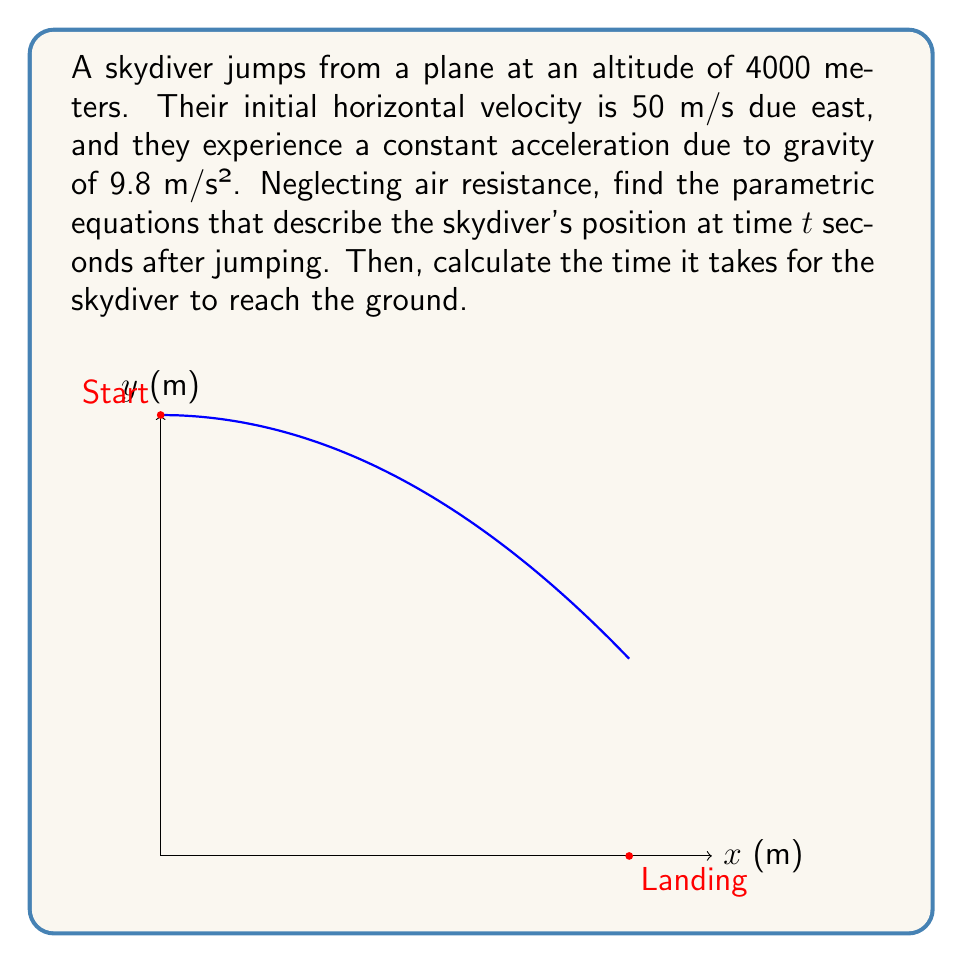Show me your answer to this math problem. Let's approach this step-by-step:

1) First, we need to set up our coordinate system. Let's use:
   - x-axis: horizontal distance traveled (positive eastward)
   - y-axis: altitude
   - t: time in seconds since the jump

2) For the x-coordinate:
   - Initial velocity in x-direction: $v_x = 50$ m/s
   - No acceleration in x-direction
   - Distance formula: $x = v_x t$
   - Therefore, $x(t) = 50t$

3) For the y-coordinate:
   - Initial altitude: $y_0 = 4000$ m
   - Initial velocity in y-direction: $v_y = 0$ m/s
   - Acceleration due to gravity: $a = -9.8$ m/s² (negative because it's downward)
   - Distance formula with acceleration: $y = y_0 + v_y t + \frac{1}{2}at^2$
   - Therefore, $y(t) = 4000 - 4.9t^2$

4) The parametric equations are:
   $$x(t) = 50t$$
   $$y(t) = 4000 - 4.9t^2$$

5) To find when the skydiver reaches the ground, we need to solve:
   $0 = 4000 - 4.9t^2$
   
   $4.9t^2 = 4000$
   
   $t^2 = \frac{4000}{4.9} \approx 816.33$
   
   $t \approx \sqrt{816.33} \approx 28.57$ seconds

Therefore, it takes approximately 28.57 seconds for the skydiver to reach the ground.
Answer: Parametric equations: $x(t) = 50t$, $y(t) = 4000 - 4.9t^2$. Time to reach ground: 28.57 seconds. 